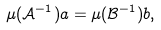<formula> <loc_0><loc_0><loc_500><loc_500>\mu ( \mathcal { A } ^ { - 1 } ) a = \mu ( \mathcal { B } ^ { - 1 } ) b ,</formula> 